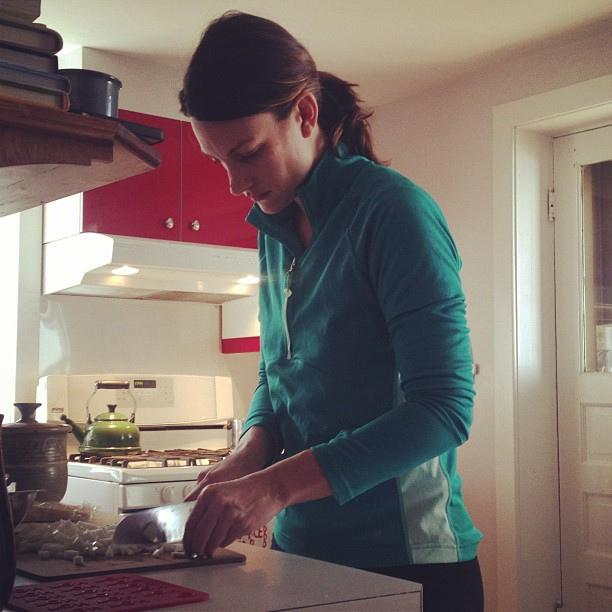Do you think she snacks often?
Concise answer only. No. What kind of fuel powers the stove?
Short answer required. Gas. What is the lady chopping?
Write a very short answer. Onions. Has this person been trained to fire a gun?
Write a very short answer. No. 